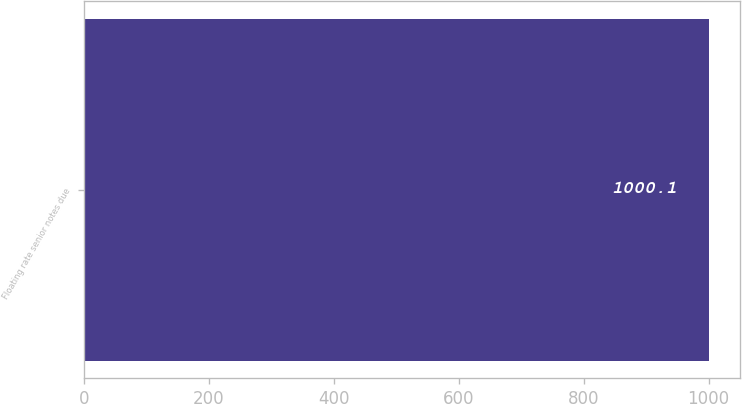<chart> <loc_0><loc_0><loc_500><loc_500><bar_chart><fcel>Floating rate senior notes due<nl><fcel>1000.1<nl></chart> 